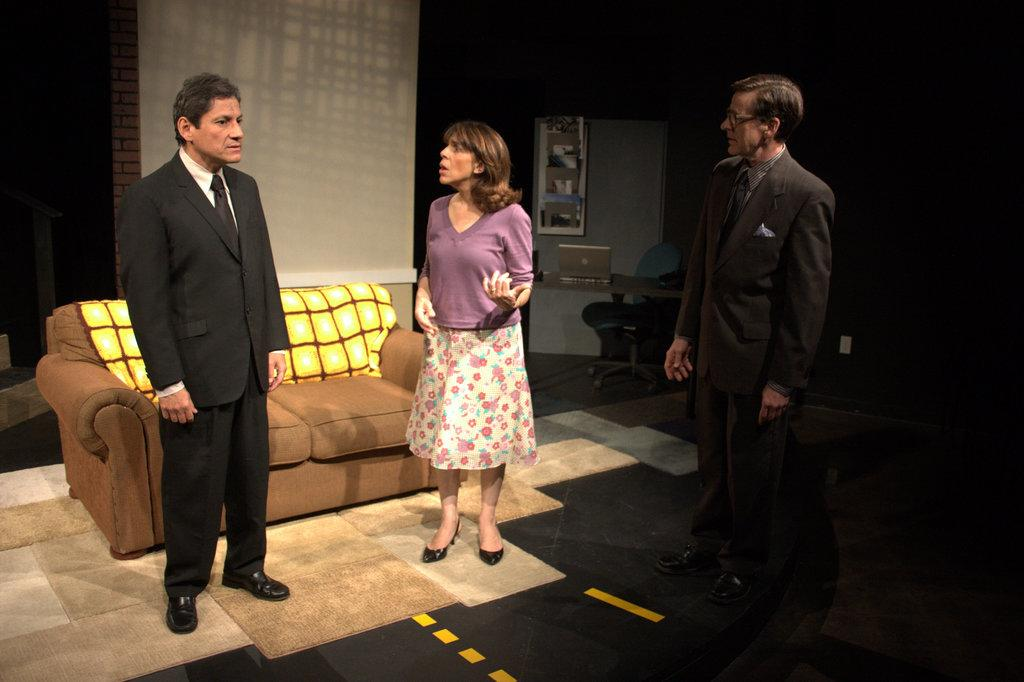How many people are in the image? There are two men and a woman in the image, making a total of three people. What type of furniture is present in the image? There is a sofa, a chair, and a table in the image. What electronic device can be seen in the image? There is a laptop in the image. What architectural feature is present in the image? There is a door in the image. Is there anything attached to the door in the image? Yes, there is an object attached to the door in the image. What type of loaf is being served on the table in the image? There is no loaf present in the image; the table contains a laptop and other items. What theory is being discussed by the people in the image? There is no indication of a discussion or a theory in the image. 